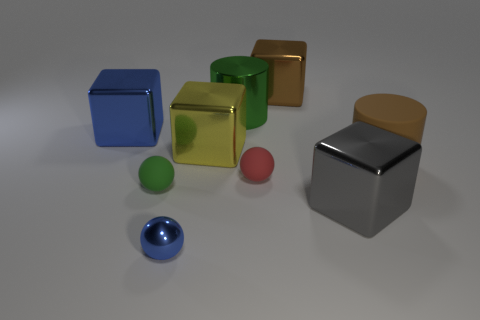Add 1 blue shiny objects. How many objects exist? 10 Subtract all balls. How many objects are left? 6 Subtract 1 blue cubes. How many objects are left? 8 Subtract all large blue shiny objects. Subtract all big gray things. How many objects are left? 7 Add 1 small blue things. How many small blue things are left? 2 Add 8 tiny rubber spheres. How many tiny rubber spheres exist? 10 